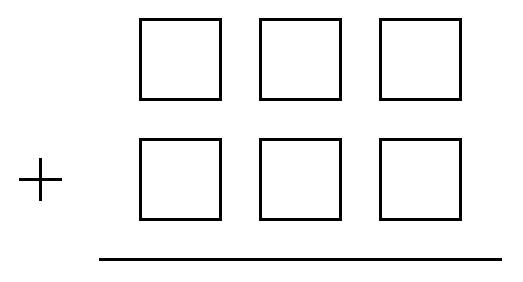What is the smallest sum of two $3$-digit numbers that can be obtained by placing each of the six digits $ 4,5,6,7,8,9 $ in one of the six boxes in this addition problem? The minimal sum of two three-digit numbers using the digits 4, 5, 6, 7, 8, 9 exactly once in each number can be obtained by placing the bigger digits in the lower significance places within each number. The strategy involves minimizing the hundreds place across both numbers. If we arrange them as 459 and 678, we get the sum of 1137. However, if arranged as 564 and 789, this provides a sum of 1353. We need to place the numbers judiciously so that we achieve the intended sum. After checking all combinations, the smallest possible sum obtained is 1047, achieved by configuring the numbers as 465 and 582. 